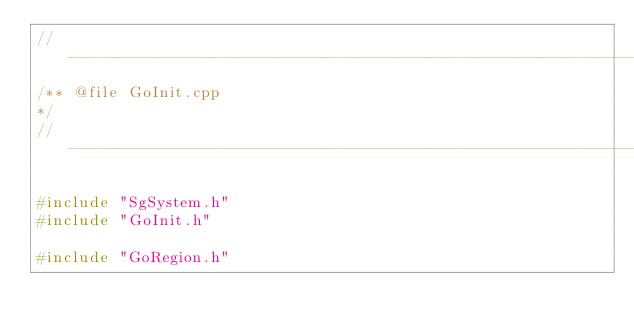<code> <loc_0><loc_0><loc_500><loc_500><_C++_>//----------------------------------------------------------------------------
/** @file GoInit.cpp
*/
//----------------------------------------------------------------------------

#include "SgSystem.h"
#include "GoInit.h"

#include "GoRegion.h"</code> 